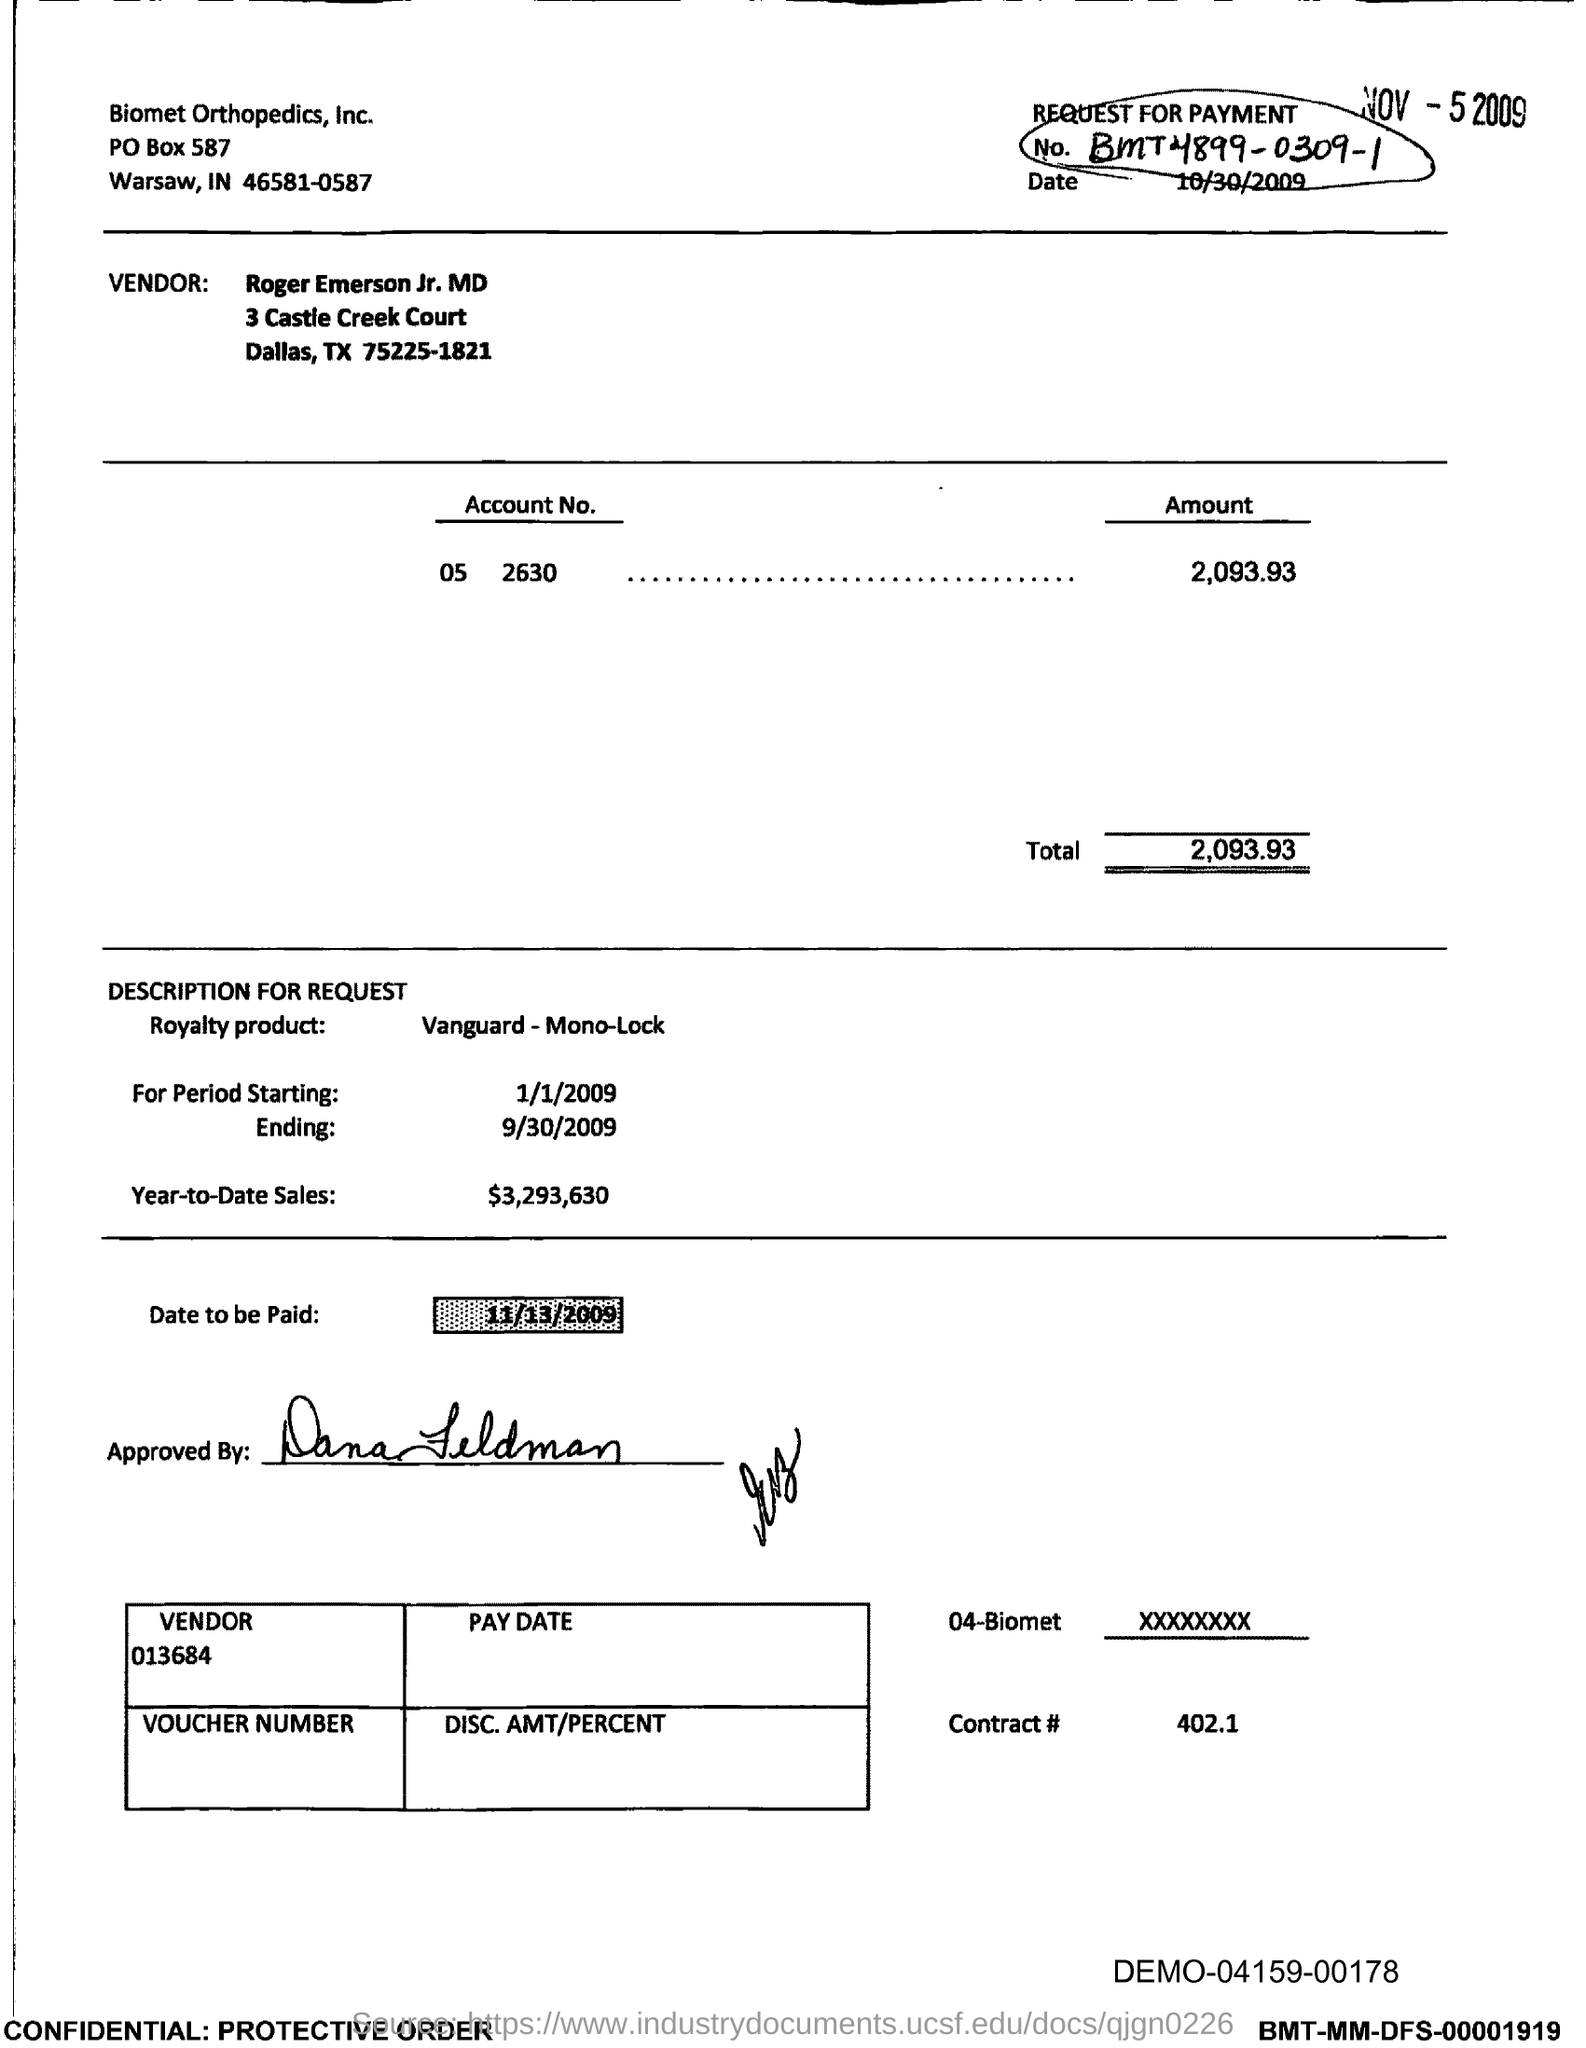Give some essential details in this illustration. The date to be paid is November 13, 2009. The amount in the account is 2,093.93. Roger Emerson Jr., MD, is the vendor. The contract number is 402.1.. The document pertains to a request for payment, detailing its purpose and relevant information. 